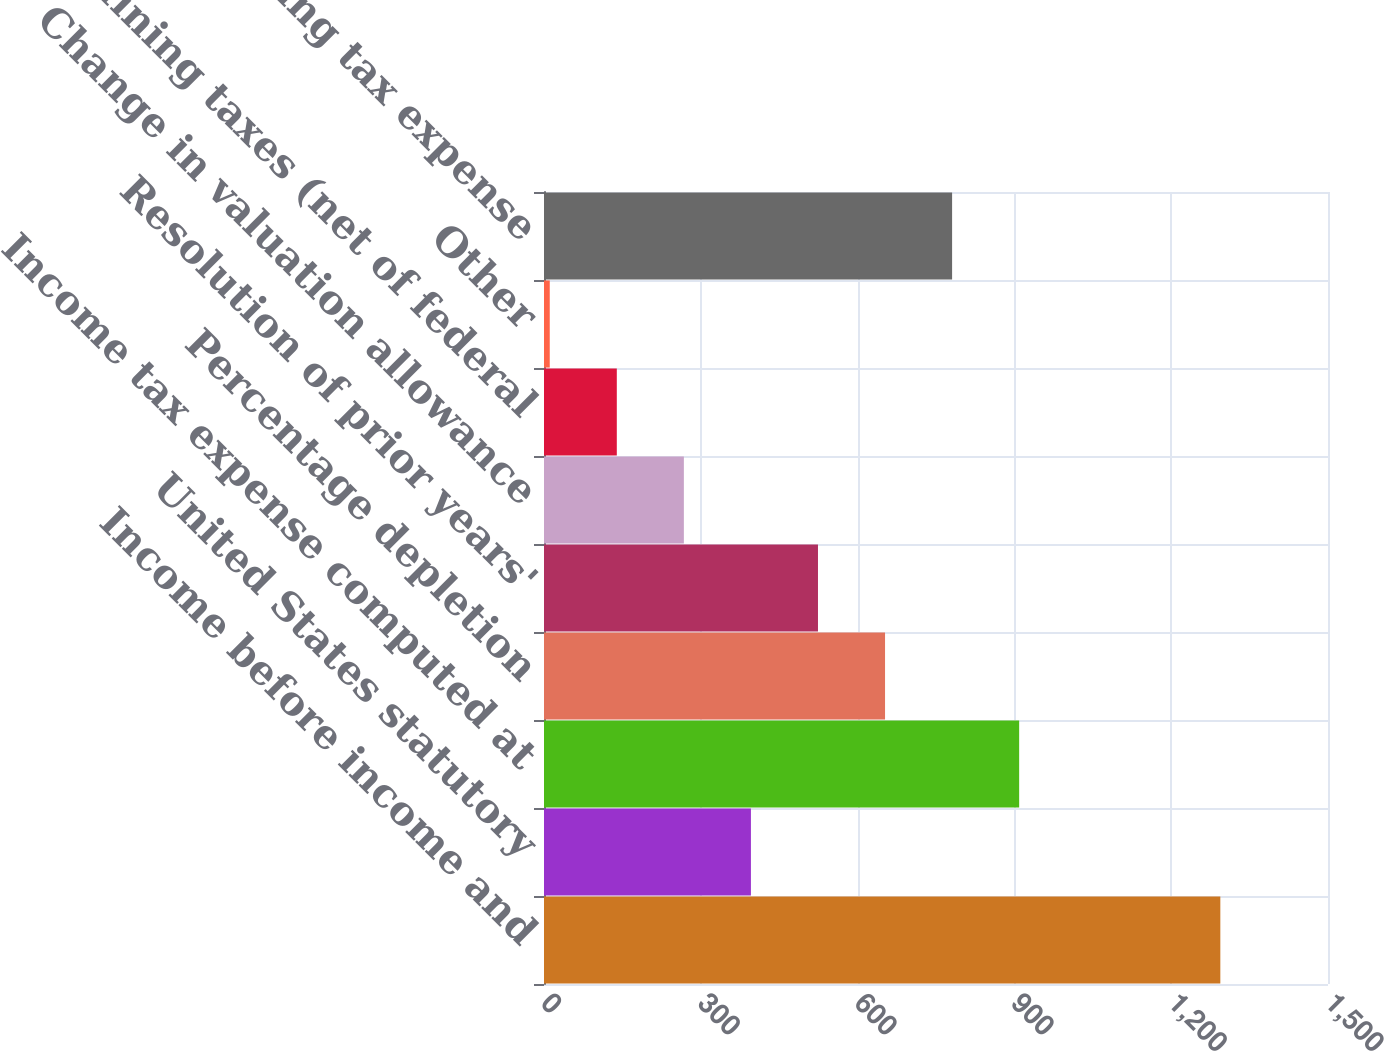<chart> <loc_0><loc_0><loc_500><loc_500><bar_chart><fcel>Income before income and<fcel>United States statutory<fcel>Income tax expense computed at<fcel>Percentage depletion<fcel>Resolution of prior years'<fcel>Change in valuation allowance<fcel>Mining taxes (net of federal<fcel>Other<fcel>Income and mining tax expense<nl><fcel>1294<fcel>395.9<fcel>909.1<fcel>652.5<fcel>524.2<fcel>267.6<fcel>139.3<fcel>11<fcel>780.8<nl></chart> 